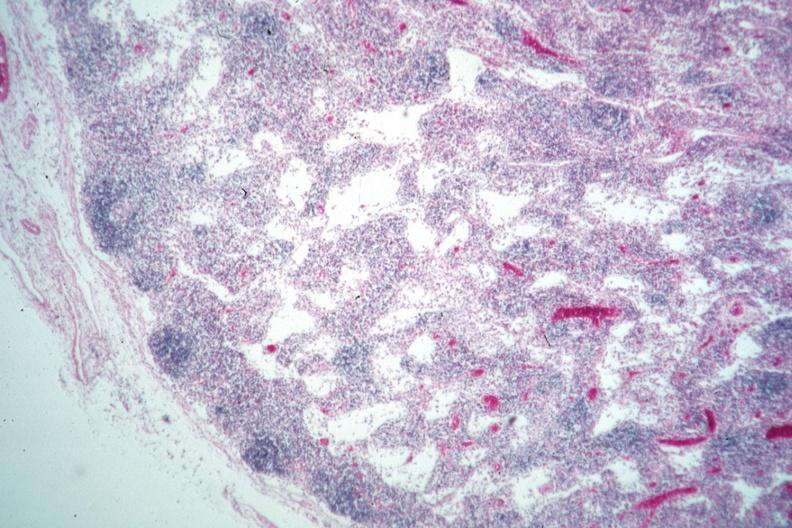what does this image show?
Answer the question using a single word or phrase. Nice example lymphocyte depleted medullary area 